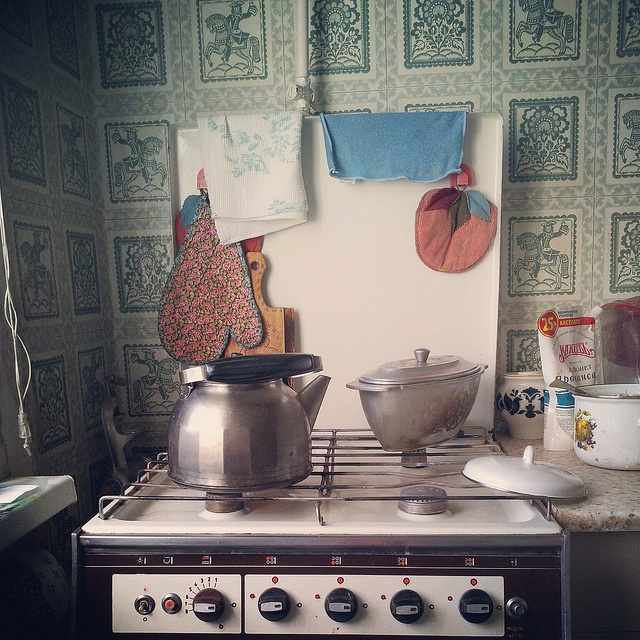Describe the objects in this image and their specific colors. I can see oven in black, darkgray, gray, and lightgray tones, bowl in black, gray, and darkgray tones, bowl in black, lightgray, and darkgray tones, and spoon in black, gray, and darkgray tones in this image. 